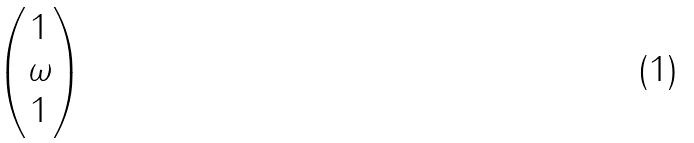<formula> <loc_0><loc_0><loc_500><loc_500>\begin{pmatrix} 1 \\ \omega \\ 1 \\ \end{pmatrix}</formula> 